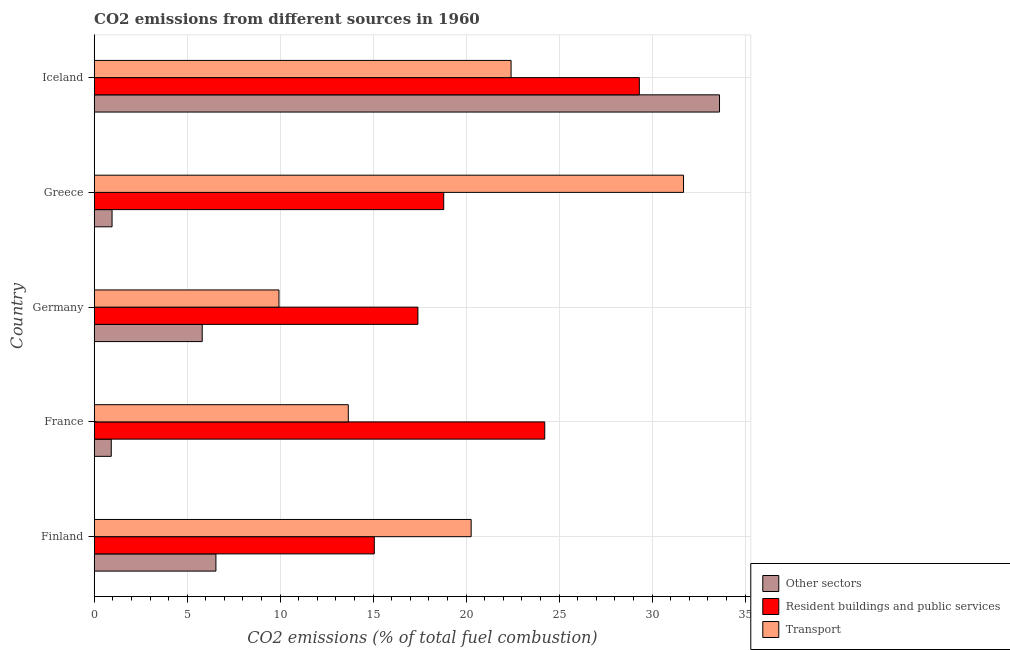How many different coloured bars are there?
Offer a very short reply. 3. Are the number of bars on each tick of the Y-axis equal?
Your response must be concise. Yes. How many bars are there on the 2nd tick from the top?
Your response must be concise. 3. How many bars are there on the 5th tick from the bottom?
Your response must be concise. 3. In how many cases, is the number of bars for a given country not equal to the number of legend labels?
Your response must be concise. 0. What is the percentage of co2 emissions from transport in Finland?
Offer a terse response. 20.27. Across all countries, what is the maximum percentage of co2 emissions from resident buildings and public services?
Offer a terse response. 29.31. Across all countries, what is the minimum percentage of co2 emissions from resident buildings and public services?
Ensure brevity in your answer.  15.06. What is the total percentage of co2 emissions from other sectors in the graph?
Your response must be concise. 47.85. What is the difference between the percentage of co2 emissions from transport in Finland and that in Greece?
Provide a short and direct response. -11.42. What is the difference between the percentage of co2 emissions from resident buildings and public services in Greece and the percentage of co2 emissions from other sectors in Germany?
Your answer should be very brief. 12.98. What is the average percentage of co2 emissions from transport per country?
Your answer should be compact. 19.59. What is the difference between the percentage of co2 emissions from resident buildings and public services and percentage of co2 emissions from transport in France?
Your answer should be compact. 10.56. What is the ratio of the percentage of co2 emissions from other sectors in Finland to that in Iceland?
Offer a very short reply. 0.2. Is the percentage of co2 emissions from resident buildings and public services in Germany less than that in Greece?
Offer a very short reply. Yes. What is the difference between the highest and the second highest percentage of co2 emissions from transport?
Keep it short and to the point. 9.27. What is the difference between the highest and the lowest percentage of co2 emissions from transport?
Your answer should be compact. 21.75. Is the sum of the percentage of co2 emissions from transport in Germany and Greece greater than the maximum percentage of co2 emissions from resident buildings and public services across all countries?
Provide a short and direct response. Yes. What does the 2nd bar from the top in France represents?
Provide a succinct answer. Resident buildings and public services. What does the 1st bar from the bottom in Germany represents?
Offer a very short reply. Other sectors. Are all the bars in the graph horizontal?
Offer a terse response. Yes. How many countries are there in the graph?
Provide a succinct answer. 5. What is the difference between two consecutive major ticks on the X-axis?
Offer a terse response. 5. Are the values on the major ticks of X-axis written in scientific E-notation?
Keep it short and to the point. No. Does the graph contain any zero values?
Provide a succinct answer. No. Does the graph contain grids?
Give a very brief answer. Yes. Where does the legend appear in the graph?
Provide a succinct answer. Bottom right. How many legend labels are there?
Your answer should be very brief. 3. What is the title of the graph?
Provide a succinct answer. CO2 emissions from different sources in 1960. What is the label or title of the X-axis?
Your response must be concise. CO2 emissions (% of total fuel combustion). What is the CO2 emissions (% of total fuel combustion) of Other sectors in Finland?
Your answer should be compact. 6.54. What is the CO2 emissions (% of total fuel combustion) in Resident buildings and public services in Finland?
Offer a terse response. 15.06. What is the CO2 emissions (% of total fuel combustion) in Transport in Finland?
Make the answer very short. 20.27. What is the CO2 emissions (% of total fuel combustion) of Other sectors in France?
Provide a short and direct response. 0.92. What is the CO2 emissions (% of total fuel combustion) of Resident buildings and public services in France?
Keep it short and to the point. 24.22. What is the CO2 emissions (% of total fuel combustion) in Transport in France?
Your answer should be very brief. 13.66. What is the CO2 emissions (% of total fuel combustion) in Other sectors in Germany?
Your answer should be compact. 5.81. What is the CO2 emissions (% of total fuel combustion) of Resident buildings and public services in Germany?
Keep it short and to the point. 17.4. What is the CO2 emissions (% of total fuel combustion) of Transport in Germany?
Offer a terse response. 9.93. What is the CO2 emissions (% of total fuel combustion) of Other sectors in Greece?
Keep it short and to the point. 0.96. What is the CO2 emissions (% of total fuel combustion) of Resident buildings and public services in Greece?
Provide a succinct answer. 18.79. What is the CO2 emissions (% of total fuel combustion) in Transport in Greece?
Your response must be concise. 31.69. What is the CO2 emissions (% of total fuel combustion) in Other sectors in Iceland?
Your response must be concise. 33.62. What is the CO2 emissions (% of total fuel combustion) in Resident buildings and public services in Iceland?
Offer a very short reply. 29.31. What is the CO2 emissions (% of total fuel combustion) of Transport in Iceland?
Give a very brief answer. 22.41. Across all countries, what is the maximum CO2 emissions (% of total fuel combustion) of Other sectors?
Give a very brief answer. 33.62. Across all countries, what is the maximum CO2 emissions (% of total fuel combustion) in Resident buildings and public services?
Provide a short and direct response. 29.31. Across all countries, what is the maximum CO2 emissions (% of total fuel combustion) of Transport?
Provide a short and direct response. 31.69. Across all countries, what is the minimum CO2 emissions (% of total fuel combustion) of Other sectors?
Provide a succinct answer. 0.92. Across all countries, what is the minimum CO2 emissions (% of total fuel combustion) of Resident buildings and public services?
Your answer should be compact. 15.06. Across all countries, what is the minimum CO2 emissions (% of total fuel combustion) in Transport?
Give a very brief answer. 9.93. What is the total CO2 emissions (% of total fuel combustion) in Other sectors in the graph?
Offer a very short reply. 47.85. What is the total CO2 emissions (% of total fuel combustion) in Resident buildings and public services in the graph?
Your response must be concise. 104.79. What is the total CO2 emissions (% of total fuel combustion) of Transport in the graph?
Your response must be concise. 97.97. What is the difference between the CO2 emissions (% of total fuel combustion) in Other sectors in Finland and that in France?
Provide a succinct answer. 5.63. What is the difference between the CO2 emissions (% of total fuel combustion) of Resident buildings and public services in Finland and that in France?
Provide a succinct answer. -9.16. What is the difference between the CO2 emissions (% of total fuel combustion) of Transport in Finland and that in France?
Provide a succinct answer. 6.6. What is the difference between the CO2 emissions (% of total fuel combustion) in Other sectors in Finland and that in Germany?
Give a very brief answer. 0.74. What is the difference between the CO2 emissions (% of total fuel combustion) in Resident buildings and public services in Finland and that in Germany?
Your response must be concise. -2.35. What is the difference between the CO2 emissions (% of total fuel combustion) of Transport in Finland and that in Germany?
Your answer should be very brief. 10.33. What is the difference between the CO2 emissions (% of total fuel combustion) of Other sectors in Finland and that in Greece?
Your response must be concise. 5.58. What is the difference between the CO2 emissions (% of total fuel combustion) in Resident buildings and public services in Finland and that in Greece?
Your answer should be compact. -3.73. What is the difference between the CO2 emissions (% of total fuel combustion) of Transport in Finland and that in Greece?
Provide a succinct answer. -11.42. What is the difference between the CO2 emissions (% of total fuel combustion) in Other sectors in Finland and that in Iceland?
Provide a short and direct response. -27.08. What is the difference between the CO2 emissions (% of total fuel combustion) of Resident buildings and public services in Finland and that in Iceland?
Your answer should be very brief. -14.25. What is the difference between the CO2 emissions (% of total fuel combustion) of Transport in Finland and that in Iceland?
Provide a short and direct response. -2.15. What is the difference between the CO2 emissions (% of total fuel combustion) in Other sectors in France and that in Germany?
Provide a short and direct response. -4.89. What is the difference between the CO2 emissions (% of total fuel combustion) of Resident buildings and public services in France and that in Germany?
Give a very brief answer. 6.82. What is the difference between the CO2 emissions (% of total fuel combustion) in Transport in France and that in Germany?
Make the answer very short. 3.73. What is the difference between the CO2 emissions (% of total fuel combustion) of Other sectors in France and that in Greece?
Provide a short and direct response. -0.04. What is the difference between the CO2 emissions (% of total fuel combustion) in Resident buildings and public services in France and that in Greece?
Keep it short and to the point. 5.43. What is the difference between the CO2 emissions (% of total fuel combustion) in Transport in France and that in Greece?
Your answer should be very brief. -18.02. What is the difference between the CO2 emissions (% of total fuel combustion) in Other sectors in France and that in Iceland?
Provide a succinct answer. -32.7. What is the difference between the CO2 emissions (% of total fuel combustion) of Resident buildings and public services in France and that in Iceland?
Make the answer very short. -5.09. What is the difference between the CO2 emissions (% of total fuel combustion) of Transport in France and that in Iceland?
Offer a terse response. -8.75. What is the difference between the CO2 emissions (% of total fuel combustion) of Other sectors in Germany and that in Greece?
Provide a succinct answer. 4.85. What is the difference between the CO2 emissions (% of total fuel combustion) of Resident buildings and public services in Germany and that in Greece?
Ensure brevity in your answer.  -1.39. What is the difference between the CO2 emissions (% of total fuel combustion) in Transport in Germany and that in Greece?
Offer a very short reply. -21.75. What is the difference between the CO2 emissions (% of total fuel combustion) of Other sectors in Germany and that in Iceland?
Offer a terse response. -27.81. What is the difference between the CO2 emissions (% of total fuel combustion) of Resident buildings and public services in Germany and that in Iceland?
Ensure brevity in your answer.  -11.91. What is the difference between the CO2 emissions (% of total fuel combustion) of Transport in Germany and that in Iceland?
Provide a succinct answer. -12.48. What is the difference between the CO2 emissions (% of total fuel combustion) in Other sectors in Greece and that in Iceland?
Provide a short and direct response. -32.66. What is the difference between the CO2 emissions (% of total fuel combustion) of Resident buildings and public services in Greece and that in Iceland?
Keep it short and to the point. -10.52. What is the difference between the CO2 emissions (% of total fuel combustion) of Transport in Greece and that in Iceland?
Offer a very short reply. 9.27. What is the difference between the CO2 emissions (% of total fuel combustion) of Other sectors in Finland and the CO2 emissions (% of total fuel combustion) of Resident buildings and public services in France?
Your answer should be very brief. -17.68. What is the difference between the CO2 emissions (% of total fuel combustion) of Other sectors in Finland and the CO2 emissions (% of total fuel combustion) of Transport in France?
Provide a short and direct response. -7.12. What is the difference between the CO2 emissions (% of total fuel combustion) of Resident buildings and public services in Finland and the CO2 emissions (% of total fuel combustion) of Transport in France?
Give a very brief answer. 1.4. What is the difference between the CO2 emissions (% of total fuel combustion) of Other sectors in Finland and the CO2 emissions (% of total fuel combustion) of Resident buildings and public services in Germany?
Offer a very short reply. -10.86. What is the difference between the CO2 emissions (% of total fuel combustion) in Other sectors in Finland and the CO2 emissions (% of total fuel combustion) in Transport in Germany?
Keep it short and to the point. -3.39. What is the difference between the CO2 emissions (% of total fuel combustion) of Resident buildings and public services in Finland and the CO2 emissions (% of total fuel combustion) of Transport in Germany?
Provide a short and direct response. 5.13. What is the difference between the CO2 emissions (% of total fuel combustion) in Other sectors in Finland and the CO2 emissions (% of total fuel combustion) in Resident buildings and public services in Greece?
Provide a short and direct response. -12.25. What is the difference between the CO2 emissions (% of total fuel combustion) in Other sectors in Finland and the CO2 emissions (% of total fuel combustion) in Transport in Greece?
Your answer should be compact. -25.14. What is the difference between the CO2 emissions (% of total fuel combustion) in Resident buildings and public services in Finland and the CO2 emissions (% of total fuel combustion) in Transport in Greece?
Give a very brief answer. -16.63. What is the difference between the CO2 emissions (% of total fuel combustion) of Other sectors in Finland and the CO2 emissions (% of total fuel combustion) of Resident buildings and public services in Iceland?
Keep it short and to the point. -22.77. What is the difference between the CO2 emissions (% of total fuel combustion) in Other sectors in Finland and the CO2 emissions (% of total fuel combustion) in Transport in Iceland?
Provide a short and direct response. -15.87. What is the difference between the CO2 emissions (% of total fuel combustion) in Resident buildings and public services in Finland and the CO2 emissions (% of total fuel combustion) in Transport in Iceland?
Offer a terse response. -7.35. What is the difference between the CO2 emissions (% of total fuel combustion) of Other sectors in France and the CO2 emissions (% of total fuel combustion) of Resident buildings and public services in Germany?
Your answer should be very brief. -16.49. What is the difference between the CO2 emissions (% of total fuel combustion) in Other sectors in France and the CO2 emissions (% of total fuel combustion) in Transport in Germany?
Give a very brief answer. -9.02. What is the difference between the CO2 emissions (% of total fuel combustion) of Resident buildings and public services in France and the CO2 emissions (% of total fuel combustion) of Transport in Germany?
Your response must be concise. 14.29. What is the difference between the CO2 emissions (% of total fuel combustion) in Other sectors in France and the CO2 emissions (% of total fuel combustion) in Resident buildings and public services in Greece?
Your answer should be compact. -17.88. What is the difference between the CO2 emissions (% of total fuel combustion) in Other sectors in France and the CO2 emissions (% of total fuel combustion) in Transport in Greece?
Offer a very short reply. -30.77. What is the difference between the CO2 emissions (% of total fuel combustion) in Resident buildings and public services in France and the CO2 emissions (% of total fuel combustion) in Transport in Greece?
Your answer should be compact. -7.46. What is the difference between the CO2 emissions (% of total fuel combustion) in Other sectors in France and the CO2 emissions (% of total fuel combustion) in Resident buildings and public services in Iceland?
Provide a succinct answer. -28.39. What is the difference between the CO2 emissions (% of total fuel combustion) of Other sectors in France and the CO2 emissions (% of total fuel combustion) of Transport in Iceland?
Make the answer very short. -21.5. What is the difference between the CO2 emissions (% of total fuel combustion) of Resident buildings and public services in France and the CO2 emissions (% of total fuel combustion) of Transport in Iceland?
Provide a succinct answer. 1.81. What is the difference between the CO2 emissions (% of total fuel combustion) of Other sectors in Germany and the CO2 emissions (% of total fuel combustion) of Resident buildings and public services in Greece?
Your response must be concise. -12.98. What is the difference between the CO2 emissions (% of total fuel combustion) of Other sectors in Germany and the CO2 emissions (% of total fuel combustion) of Transport in Greece?
Keep it short and to the point. -25.88. What is the difference between the CO2 emissions (% of total fuel combustion) of Resident buildings and public services in Germany and the CO2 emissions (% of total fuel combustion) of Transport in Greece?
Offer a very short reply. -14.28. What is the difference between the CO2 emissions (% of total fuel combustion) in Other sectors in Germany and the CO2 emissions (% of total fuel combustion) in Resident buildings and public services in Iceland?
Make the answer very short. -23.5. What is the difference between the CO2 emissions (% of total fuel combustion) in Other sectors in Germany and the CO2 emissions (% of total fuel combustion) in Transport in Iceland?
Offer a terse response. -16.61. What is the difference between the CO2 emissions (% of total fuel combustion) of Resident buildings and public services in Germany and the CO2 emissions (% of total fuel combustion) of Transport in Iceland?
Provide a succinct answer. -5.01. What is the difference between the CO2 emissions (% of total fuel combustion) of Other sectors in Greece and the CO2 emissions (% of total fuel combustion) of Resident buildings and public services in Iceland?
Your response must be concise. -28.35. What is the difference between the CO2 emissions (% of total fuel combustion) in Other sectors in Greece and the CO2 emissions (% of total fuel combustion) in Transport in Iceland?
Your answer should be compact. -21.45. What is the difference between the CO2 emissions (% of total fuel combustion) of Resident buildings and public services in Greece and the CO2 emissions (% of total fuel combustion) of Transport in Iceland?
Offer a very short reply. -3.62. What is the average CO2 emissions (% of total fuel combustion) of Other sectors per country?
Give a very brief answer. 9.57. What is the average CO2 emissions (% of total fuel combustion) in Resident buildings and public services per country?
Give a very brief answer. 20.96. What is the average CO2 emissions (% of total fuel combustion) of Transport per country?
Give a very brief answer. 19.59. What is the difference between the CO2 emissions (% of total fuel combustion) of Other sectors and CO2 emissions (% of total fuel combustion) of Resident buildings and public services in Finland?
Your answer should be compact. -8.52. What is the difference between the CO2 emissions (% of total fuel combustion) in Other sectors and CO2 emissions (% of total fuel combustion) in Transport in Finland?
Offer a terse response. -13.72. What is the difference between the CO2 emissions (% of total fuel combustion) in Resident buildings and public services and CO2 emissions (% of total fuel combustion) in Transport in Finland?
Your answer should be compact. -5.21. What is the difference between the CO2 emissions (% of total fuel combustion) of Other sectors and CO2 emissions (% of total fuel combustion) of Resident buildings and public services in France?
Your answer should be compact. -23.31. What is the difference between the CO2 emissions (% of total fuel combustion) in Other sectors and CO2 emissions (% of total fuel combustion) in Transport in France?
Make the answer very short. -12.75. What is the difference between the CO2 emissions (% of total fuel combustion) of Resident buildings and public services and CO2 emissions (% of total fuel combustion) of Transport in France?
Provide a short and direct response. 10.56. What is the difference between the CO2 emissions (% of total fuel combustion) in Other sectors and CO2 emissions (% of total fuel combustion) in Resident buildings and public services in Germany?
Your response must be concise. -11.6. What is the difference between the CO2 emissions (% of total fuel combustion) in Other sectors and CO2 emissions (% of total fuel combustion) in Transport in Germany?
Your response must be concise. -4.13. What is the difference between the CO2 emissions (% of total fuel combustion) in Resident buildings and public services and CO2 emissions (% of total fuel combustion) in Transport in Germany?
Keep it short and to the point. 7.47. What is the difference between the CO2 emissions (% of total fuel combustion) in Other sectors and CO2 emissions (% of total fuel combustion) in Resident buildings and public services in Greece?
Give a very brief answer. -17.83. What is the difference between the CO2 emissions (% of total fuel combustion) in Other sectors and CO2 emissions (% of total fuel combustion) in Transport in Greece?
Offer a terse response. -30.73. What is the difference between the CO2 emissions (% of total fuel combustion) in Resident buildings and public services and CO2 emissions (% of total fuel combustion) in Transport in Greece?
Offer a terse response. -12.89. What is the difference between the CO2 emissions (% of total fuel combustion) of Other sectors and CO2 emissions (% of total fuel combustion) of Resident buildings and public services in Iceland?
Provide a succinct answer. 4.31. What is the difference between the CO2 emissions (% of total fuel combustion) in Other sectors and CO2 emissions (% of total fuel combustion) in Transport in Iceland?
Offer a very short reply. 11.21. What is the difference between the CO2 emissions (% of total fuel combustion) of Resident buildings and public services and CO2 emissions (% of total fuel combustion) of Transport in Iceland?
Keep it short and to the point. 6.9. What is the ratio of the CO2 emissions (% of total fuel combustion) of Other sectors in Finland to that in France?
Keep it short and to the point. 7.14. What is the ratio of the CO2 emissions (% of total fuel combustion) in Resident buildings and public services in Finland to that in France?
Offer a very short reply. 0.62. What is the ratio of the CO2 emissions (% of total fuel combustion) of Transport in Finland to that in France?
Ensure brevity in your answer.  1.48. What is the ratio of the CO2 emissions (% of total fuel combustion) of Other sectors in Finland to that in Germany?
Keep it short and to the point. 1.13. What is the ratio of the CO2 emissions (% of total fuel combustion) of Resident buildings and public services in Finland to that in Germany?
Provide a succinct answer. 0.87. What is the ratio of the CO2 emissions (% of total fuel combustion) in Transport in Finland to that in Germany?
Your answer should be compact. 2.04. What is the ratio of the CO2 emissions (% of total fuel combustion) of Other sectors in Finland to that in Greece?
Provide a succinct answer. 6.82. What is the ratio of the CO2 emissions (% of total fuel combustion) in Resident buildings and public services in Finland to that in Greece?
Make the answer very short. 0.8. What is the ratio of the CO2 emissions (% of total fuel combustion) of Transport in Finland to that in Greece?
Keep it short and to the point. 0.64. What is the ratio of the CO2 emissions (% of total fuel combustion) in Other sectors in Finland to that in Iceland?
Keep it short and to the point. 0.19. What is the ratio of the CO2 emissions (% of total fuel combustion) in Resident buildings and public services in Finland to that in Iceland?
Make the answer very short. 0.51. What is the ratio of the CO2 emissions (% of total fuel combustion) in Transport in Finland to that in Iceland?
Your response must be concise. 0.9. What is the ratio of the CO2 emissions (% of total fuel combustion) of Other sectors in France to that in Germany?
Your answer should be very brief. 0.16. What is the ratio of the CO2 emissions (% of total fuel combustion) of Resident buildings and public services in France to that in Germany?
Your answer should be very brief. 1.39. What is the ratio of the CO2 emissions (% of total fuel combustion) of Transport in France to that in Germany?
Ensure brevity in your answer.  1.38. What is the ratio of the CO2 emissions (% of total fuel combustion) of Other sectors in France to that in Greece?
Provide a succinct answer. 0.96. What is the ratio of the CO2 emissions (% of total fuel combustion) of Resident buildings and public services in France to that in Greece?
Offer a very short reply. 1.29. What is the ratio of the CO2 emissions (% of total fuel combustion) of Transport in France to that in Greece?
Make the answer very short. 0.43. What is the ratio of the CO2 emissions (% of total fuel combustion) in Other sectors in France to that in Iceland?
Offer a very short reply. 0.03. What is the ratio of the CO2 emissions (% of total fuel combustion) of Resident buildings and public services in France to that in Iceland?
Provide a succinct answer. 0.83. What is the ratio of the CO2 emissions (% of total fuel combustion) of Transport in France to that in Iceland?
Your answer should be compact. 0.61. What is the ratio of the CO2 emissions (% of total fuel combustion) of Other sectors in Germany to that in Greece?
Give a very brief answer. 6.05. What is the ratio of the CO2 emissions (% of total fuel combustion) in Resident buildings and public services in Germany to that in Greece?
Ensure brevity in your answer.  0.93. What is the ratio of the CO2 emissions (% of total fuel combustion) in Transport in Germany to that in Greece?
Ensure brevity in your answer.  0.31. What is the ratio of the CO2 emissions (% of total fuel combustion) in Other sectors in Germany to that in Iceland?
Offer a very short reply. 0.17. What is the ratio of the CO2 emissions (% of total fuel combustion) in Resident buildings and public services in Germany to that in Iceland?
Offer a terse response. 0.59. What is the ratio of the CO2 emissions (% of total fuel combustion) of Transport in Germany to that in Iceland?
Provide a succinct answer. 0.44. What is the ratio of the CO2 emissions (% of total fuel combustion) of Other sectors in Greece to that in Iceland?
Your answer should be very brief. 0.03. What is the ratio of the CO2 emissions (% of total fuel combustion) of Resident buildings and public services in Greece to that in Iceland?
Provide a short and direct response. 0.64. What is the ratio of the CO2 emissions (% of total fuel combustion) in Transport in Greece to that in Iceland?
Offer a terse response. 1.41. What is the difference between the highest and the second highest CO2 emissions (% of total fuel combustion) in Other sectors?
Your answer should be very brief. 27.08. What is the difference between the highest and the second highest CO2 emissions (% of total fuel combustion) of Resident buildings and public services?
Provide a short and direct response. 5.09. What is the difference between the highest and the second highest CO2 emissions (% of total fuel combustion) of Transport?
Offer a very short reply. 9.27. What is the difference between the highest and the lowest CO2 emissions (% of total fuel combustion) in Other sectors?
Offer a terse response. 32.7. What is the difference between the highest and the lowest CO2 emissions (% of total fuel combustion) in Resident buildings and public services?
Your answer should be very brief. 14.25. What is the difference between the highest and the lowest CO2 emissions (% of total fuel combustion) in Transport?
Provide a short and direct response. 21.75. 